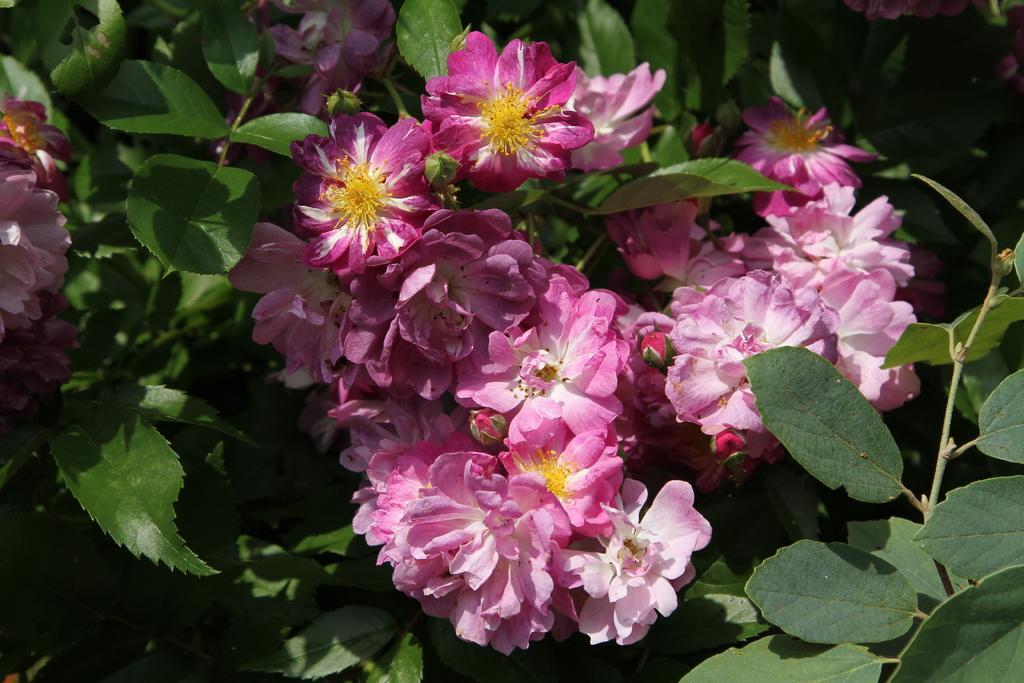Could you give a brief overview of what you see in this image? In this image we can see plants with flowers. 